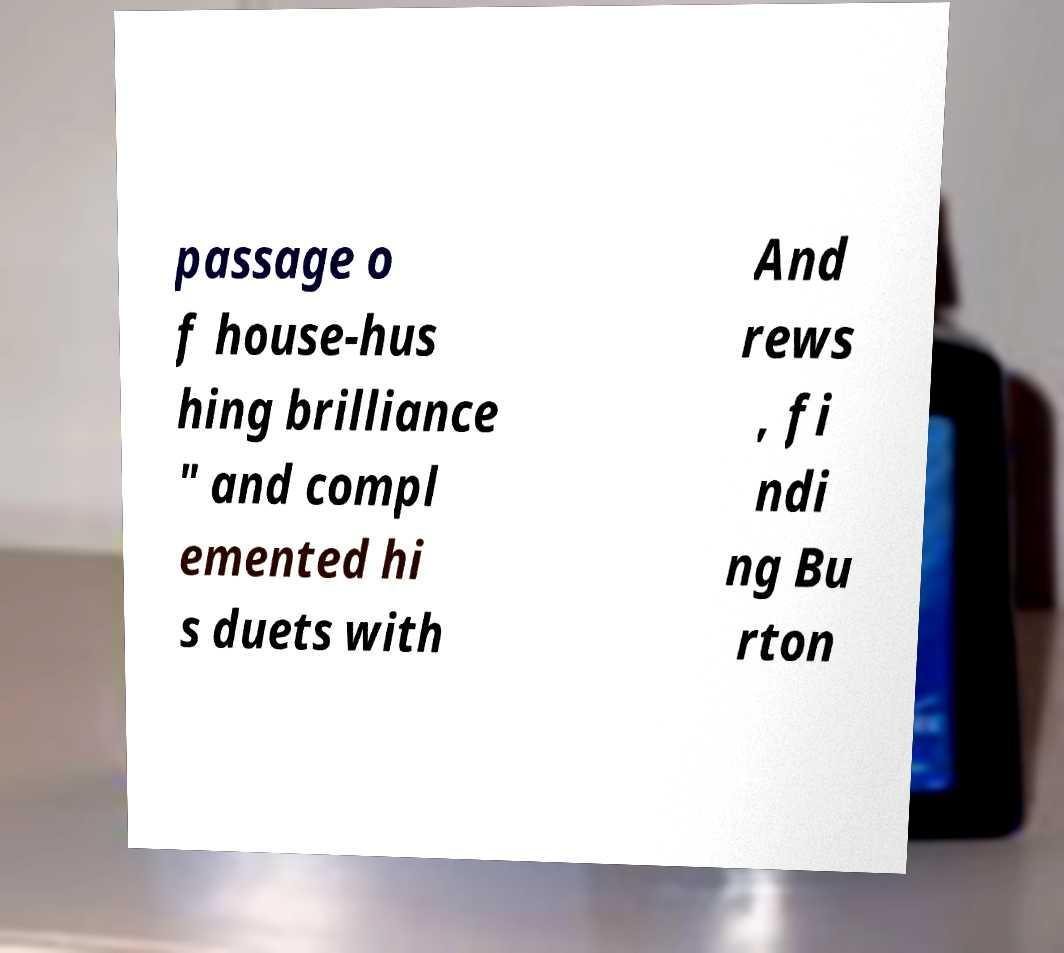Could you assist in decoding the text presented in this image and type it out clearly? passage o f house-hus hing brilliance " and compl emented hi s duets with And rews , fi ndi ng Bu rton 